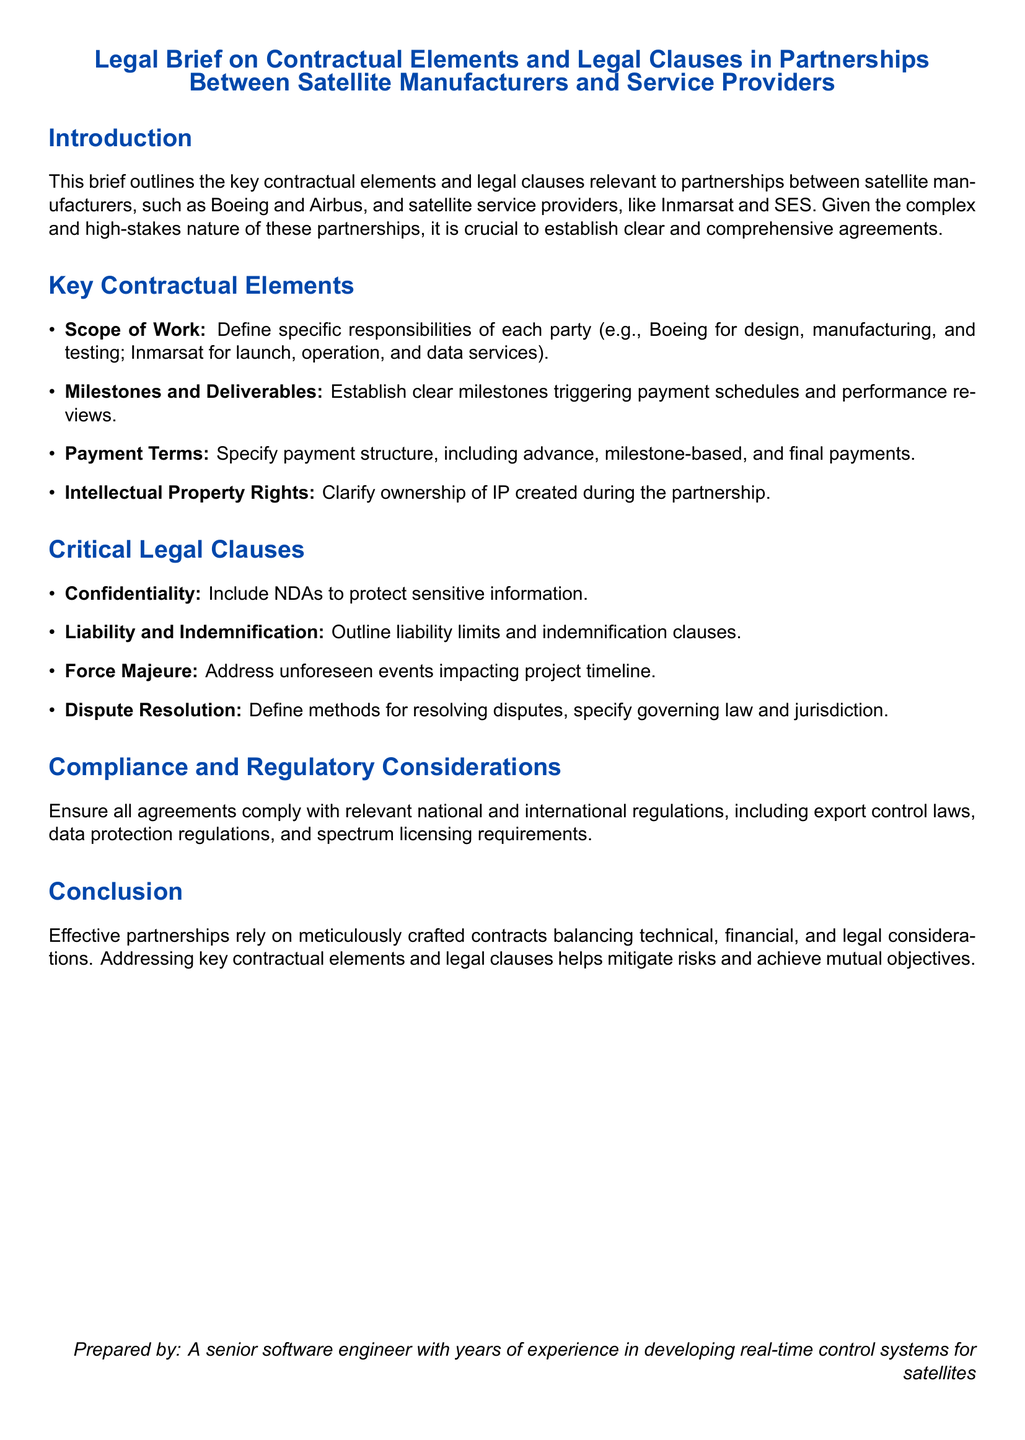What is the title of the document? The title is stated at the beginning of the document, summarizing its content.
Answer: Legal Brief on Contractual Elements and Legal Clauses in Partnerships Between Satellite Manufacturers and Service Providers What are the two categories of key contractual elements mentioned? The document lists specific contractual elements under two categories: Scope of Work and Milestones and Deliverables.
Answer: Scope of Work and Milestones and Deliverables What is one responsibility of Boeing as per the scope of work? The responsibilities of Boeing are specified within the Scope of Work section, indicating their role in the partnership.
Answer: Design, manufacturing, and testing What clause addresses unforeseen project delays? The legal clauses section discusses various important clauses, one of which deals with unexpected events affecting timelines.
Answer: Force Majeure What must be defined for resolving disputes? The critical legal clauses section highlights the need for clarity regarding dispute resolution methods.
Answer: Dispute Resolution Which two companies are mentioned as examples of satellite manufacturers? The introduction lists examples of satellite manufacturers as part of the context.
Answer: Boeing and Airbus What legal consideration is emphasized for compliance? The document under Compliance and Regulatory Considerations indicates the need for agreements to align with specific laws.
Answer: National and international regulations What type of agreement must include NDAs? The context of confidentiality is specified, indicating the need for certain documents to protect sensitive information.
Answer: Confidentiality What is the purpose of the document? The introduction outlines the main goal of the legal brief, focusing on establishing agreements in partnerships.
Answer: To outline key contractual elements and legal clauses 